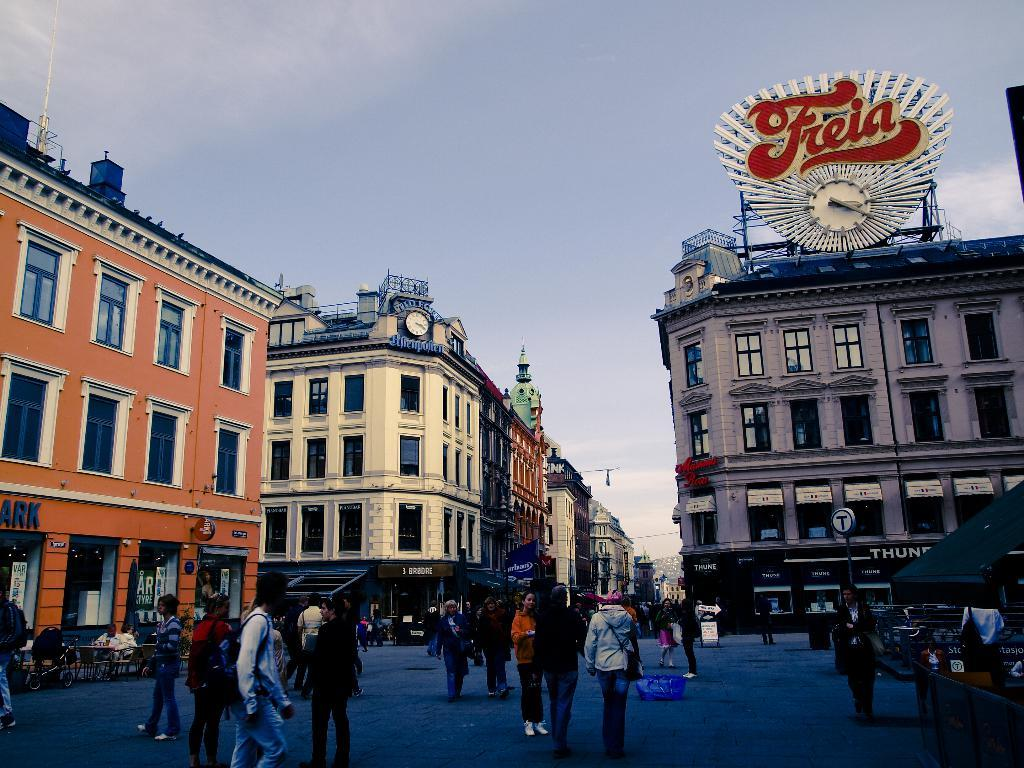What are the people in the image doing? The group of people is standing on the road. What type of furniture can be seen in the image? There are chairs and tables in the image. What structures are visible in the image? There are buildings in the image. What other objects can be seen in the image? There are poles, clocks, and boards in the image. What is visible in the background of the image? The sky is visible in the background of the image. What story is being told by the letters on the boards in the image? There are no letters or stories present on the boards in the image. Is there any water visible in the image? There is no water present in the image. 